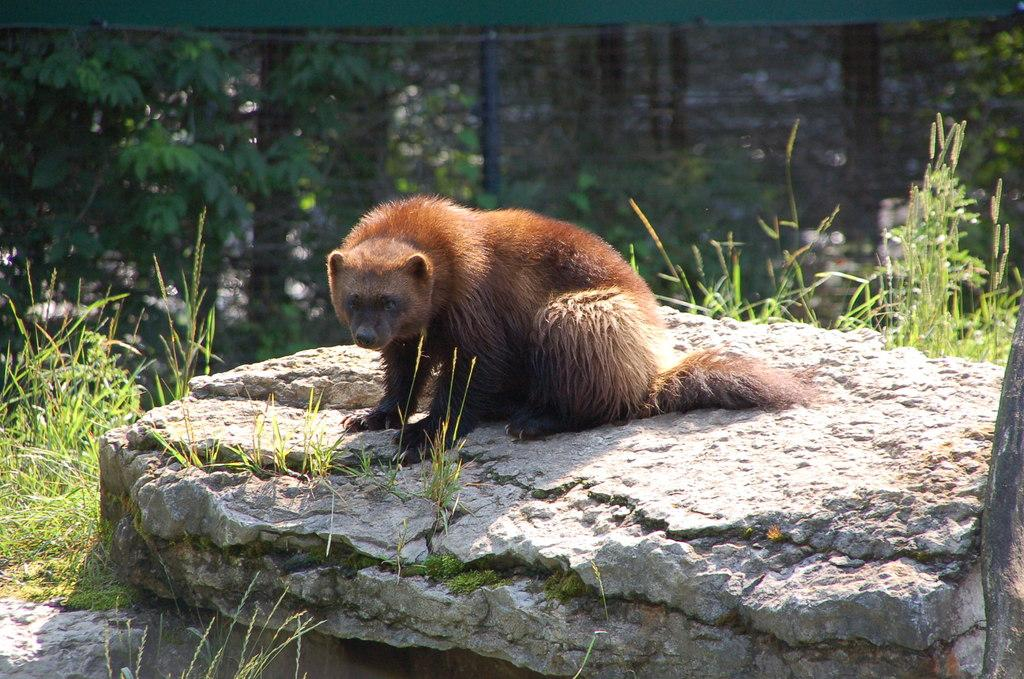What type of animal is in the image? There is a wolverine animal in the image. Where is the wolverine located? The wolverine is on a rock. What type of vegetation can be seen in the image? There is grass visible in the image. How would you describe the background of the image? The background of the image is blurred. What temperature should the oven be set to in order to cook the wolverine in the image? There is no oven present in the image, and the wolverine is an animal, not food to be cooked. 